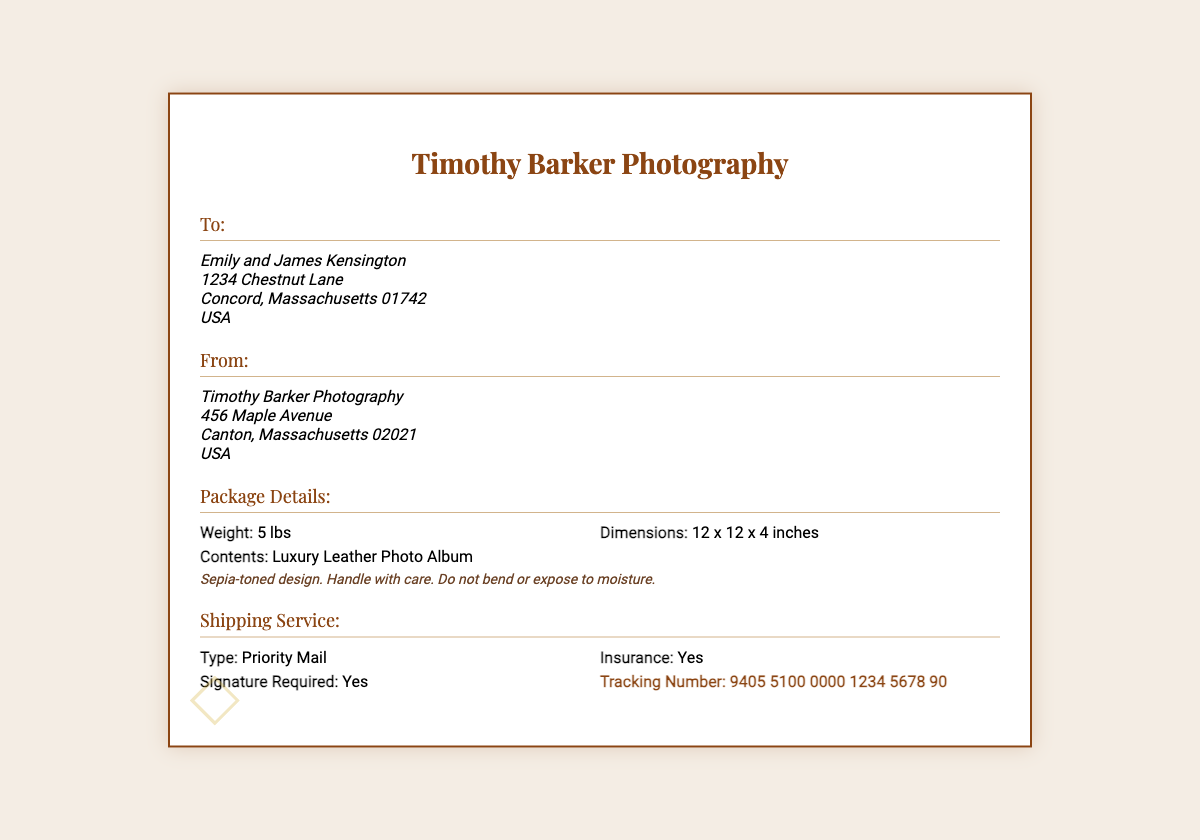What is the name of the recipients? The names of the recipients, as listed in the document, are Emily and James Kensington.
Answer: Emily and James Kensington What is the shipping address? The shipping address includes the street, city, state, ZIP code, and country for the recipients.
Answer: 1234 Chestnut Lane, Concord, Massachusetts 01742, USA What is the weight of the package? The weight of the package is specified in the document, indicating how heavy it is.
Answer: 5 lbs What are the dimensions of the package? The dimensions provide the size of the package in three measurements.
Answer: 12 x 12 x 4 inches What type of shipping service is used? The document outlines the type of shipping service selected for this package.
Answer: Priority Mail Is insurance included with the shipping? The document specifies whether insurance is provided for the shipment.
Answer: Yes What is the tracking number? The tracking number is provided in the document for monitoring the shipment's progress.
Answer: 9405 5100 0000 1234 5678 90 What should be noted about the contents? The document includes special handling instructions regarding the contents of the package.
Answer: Handle with care. Do not bend or expose to moisture What kind of album is shipped? The document identifies the type of item being shipped to the recipients.
Answer: Luxury Leather Photo Album 